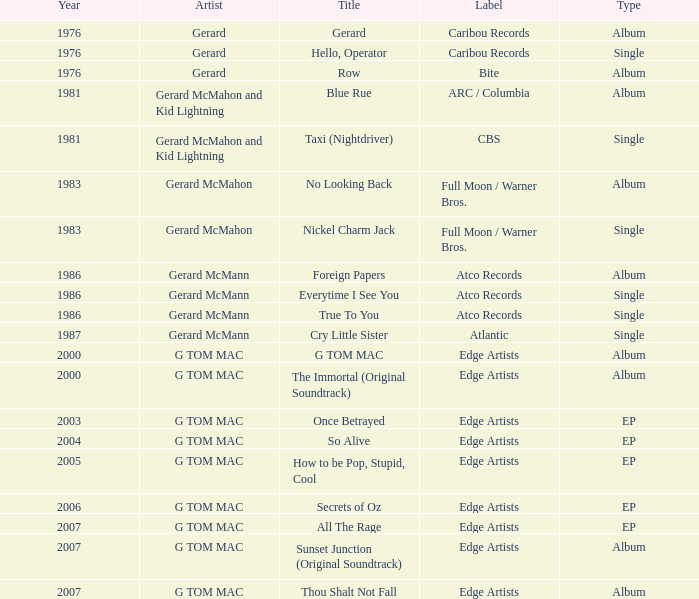Identify the year with an atco records label and an album classification? question 2 1986.0. 